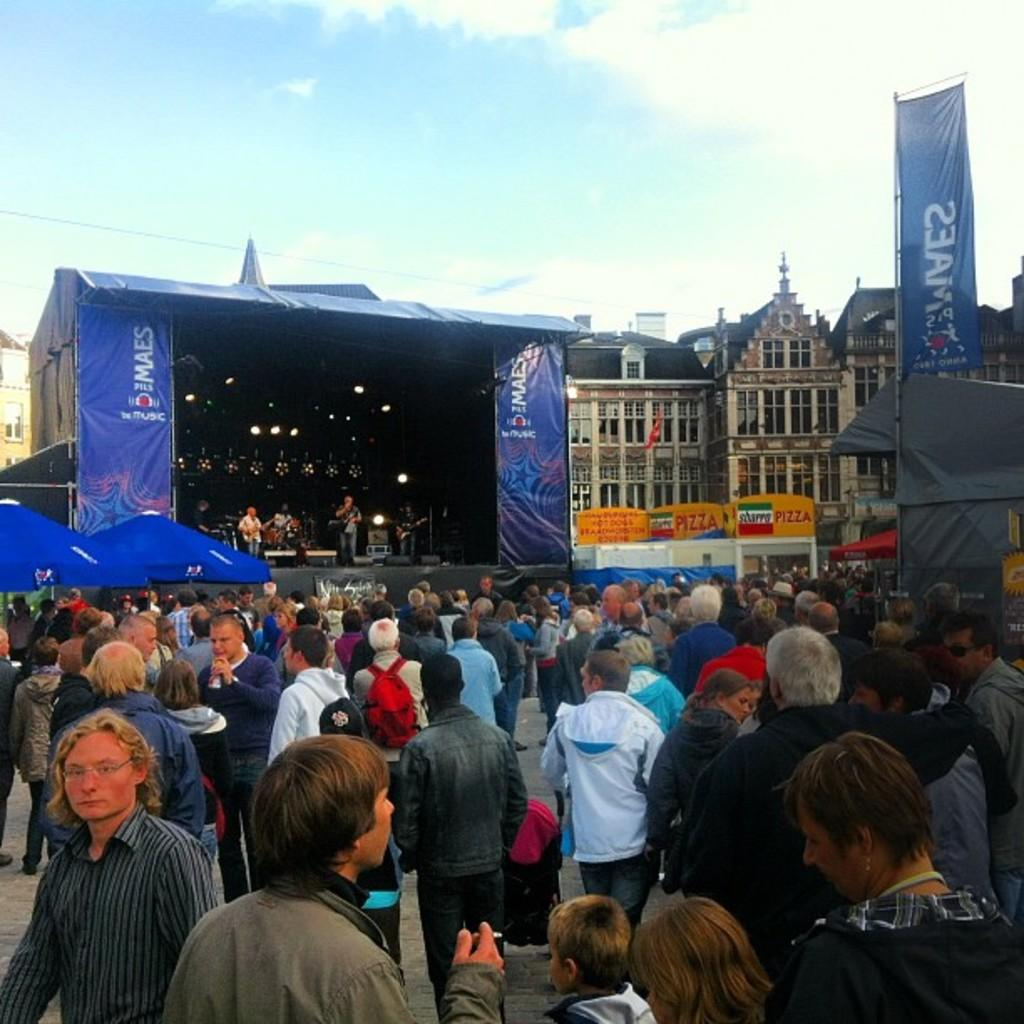Who can be seen in the image? There are people in the image. Where are some of the people located in the image? Some people are standing on a stage. What can be seen in the distance behind the people? There are buildings in the background of the image. What is visible in the sky in the background of the image? Clouds are visible in the sky in the background of the image. Can you describe the maid in the image? There is no maid present in the image. What type of things can be seen on the squirrel in the image? There is no squirrel present in the image. 